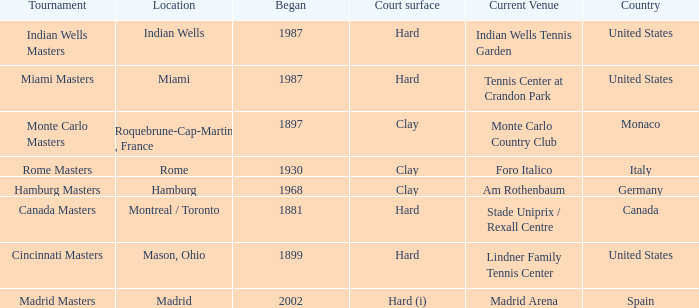What is the current venue for the Miami Masters tournament? Tennis Center at Crandon Park. 